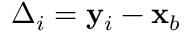Convert formula to latex. <formula><loc_0><loc_0><loc_500><loc_500>\Delta _ { i } = y _ { i } - x _ { b }</formula> 